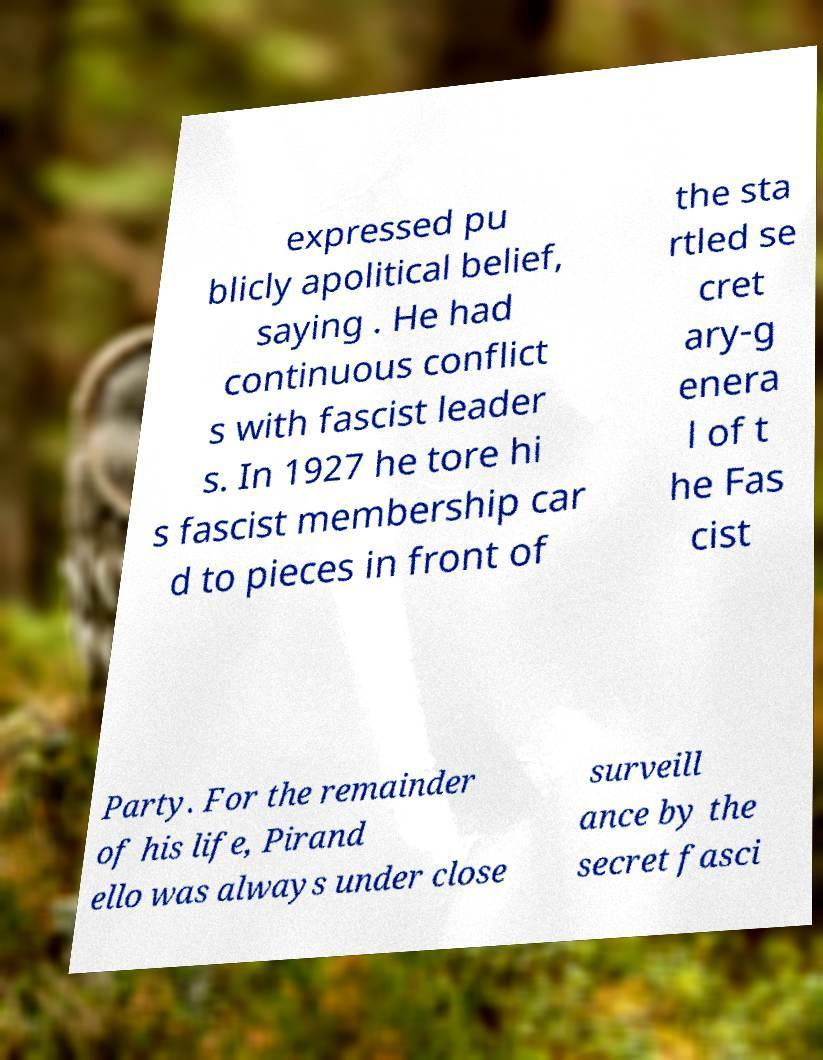Please read and relay the text visible in this image. What does it say? expressed pu blicly apolitical belief, saying . He had continuous conflict s with fascist leader s. In 1927 he tore hi s fascist membership car d to pieces in front of the sta rtled se cret ary-g enera l of t he Fas cist Party. For the remainder of his life, Pirand ello was always under close surveill ance by the secret fasci 